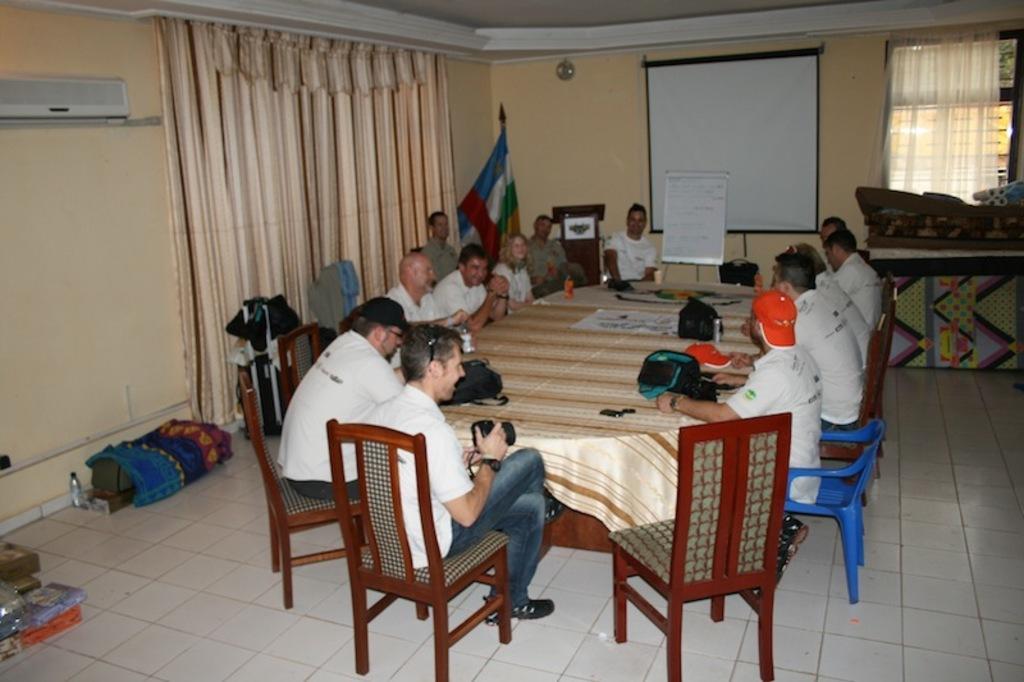In one or two sentences, can you explain what this image depicts? In the picture we can see a set of people sitting on the chairs near the table, on the table we can find a tablecloth, some bags, mobiles, a paper with picture, and painting. In the background we can find a board with some information on it and a screen to the wall and we can also find a air cooler, just beside to it there is a curtain, and on the floor we can see some bags, bottle and books. 